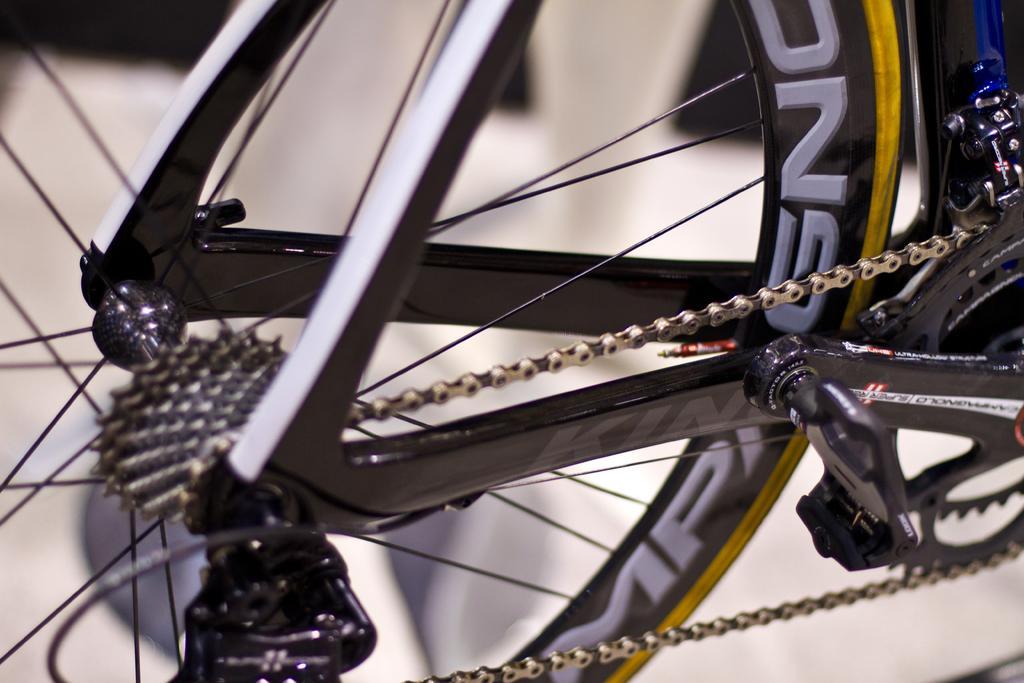How would you summarize this image in a sentence or two? In this image I can see a chain and spokes of a wheel of a bicycle. 